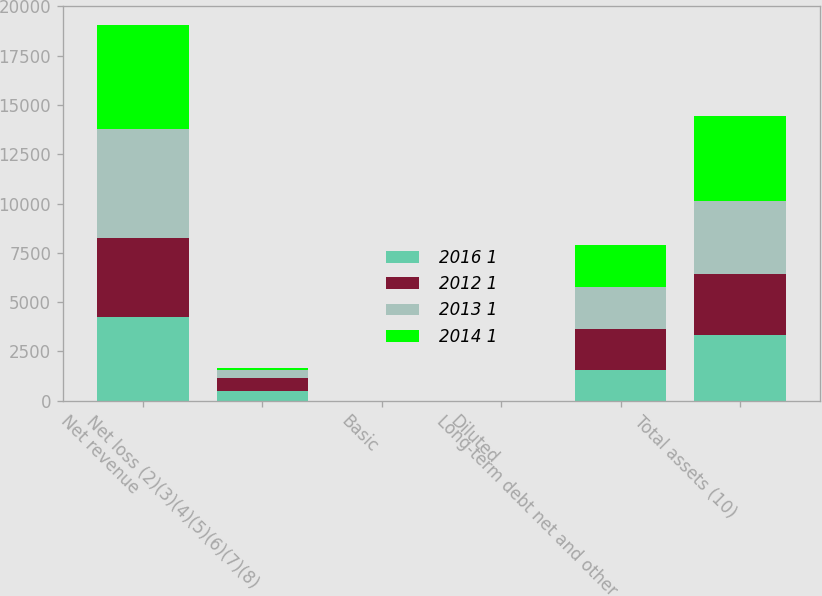Convert chart to OTSL. <chart><loc_0><loc_0><loc_500><loc_500><stacked_bar_chart><ecel><fcel>Net revenue<fcel>Net loss (2)(3)(4)(5)(6)(7)(8)<fcel>Basic<fcel>Diluted<fcel>Long-term debt net and other<fcel>Total assets (10)<nl><fcel>2016 1<fcel>4272<fcel>497<fcel>0.6<fcel>0.6<fcel>1559<fcel>3321<nl><fcel>2012 1<fcel>3991<fcel>660<fcel>0.84<fcel>0.84<fcel>2093<fcel>3084<nl><fcel>2013 1<fcel>5506<fcel>403<fcel>0.53<fcel>0.53<fcel>2110<fcel>3737<nl><fcel>2014 1<fcel>5299<fcel>83<fcel>0.11<fcel>0.11<fcel>2153<fcel>4315<nl></chart> 